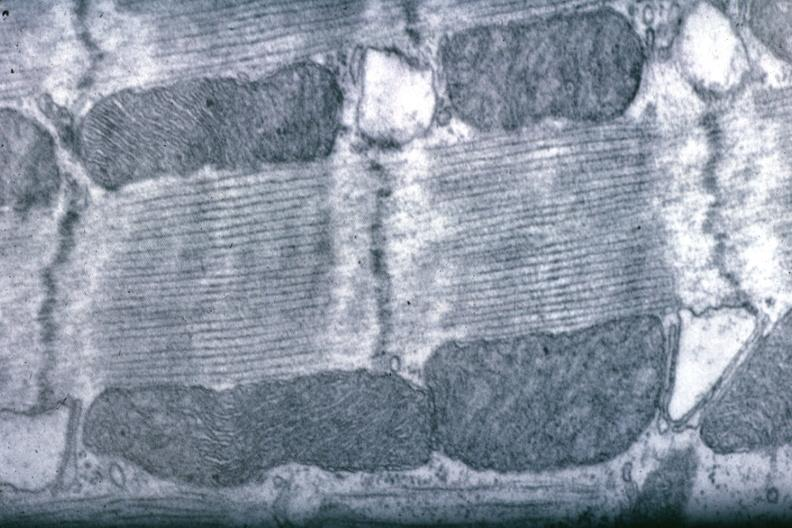s myocardium present?
Answer the question using a single word or phrase. Yes 